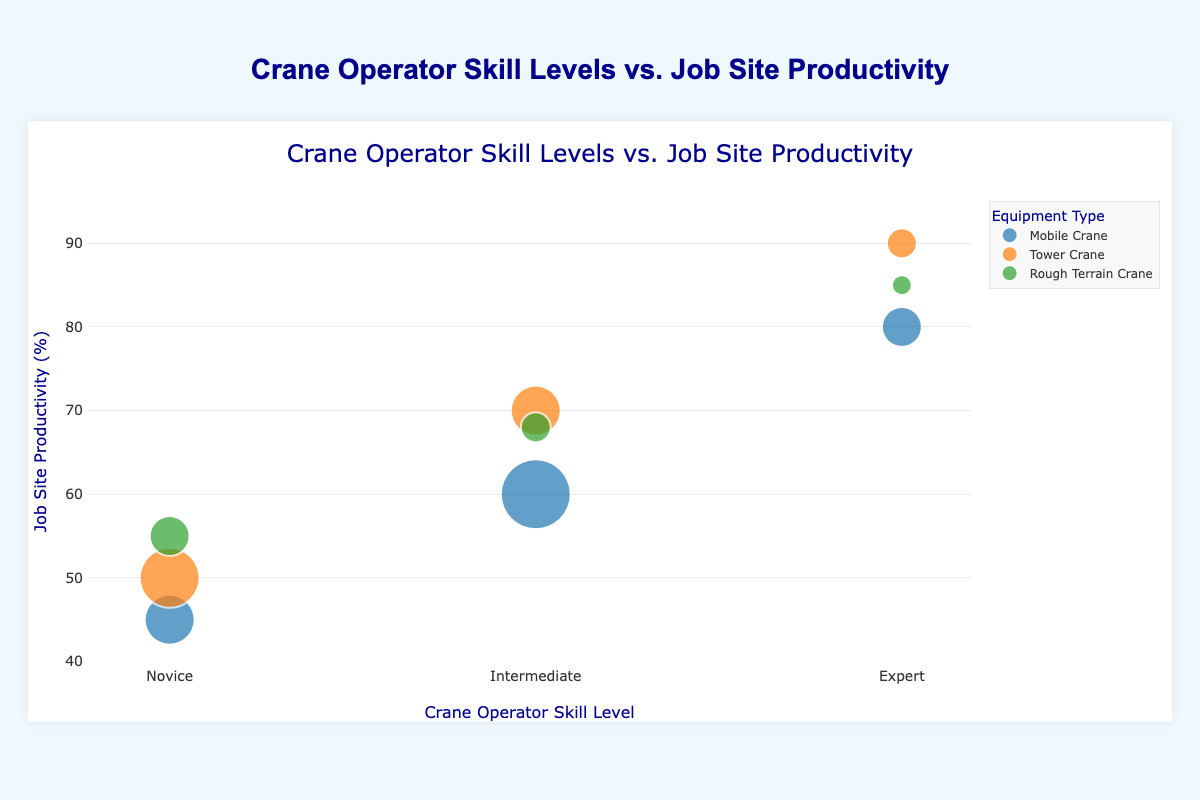what is the relationship between the skill levels of crane operators and job site productivity for tower cranes? As the skill level of crane operators increases, job site productivity also increases for tower cranes. Novice operators achieve 50%, Intermediate operators achieve 70%, and Expert operators achieve 90%.
Answer: Higher skill levels lead to higher productivity What is the number of data points in the figure? There are three equipment types (Mobile Crane, Tower Crane, Rough Terrain Crane) and each has three skill levels (Novice, Intermediate, Expert), resulting in 3 x 3 = 9 data points.
Answer: 9 What is the productivity of expert operators using Rough Terrain Cranes? According to the figure, expert operators using Rough Terrain Cranes have a job site productivity of 85%.
Answer: 85% Which equipment type has the lowest productivity for intermediate operators? By referring to the data points for intermediate operators, we see that Mobile Cranes achieve 60%, Tower Cranes achieve 70%, and Rough Terrain Cranes achieve 68%. The lowest productivity for intermediate operators is with Mobile Cranes.
Answer: Mobile Cranes How many novice operators are there for each equipment type? According to the figure:
- Mobile Cranes have 5 novice operators.
- Tower Cranes have 6 novice operators.
- Rough Terrain Cranes have 4 novice operators.
Answer: 5 for Mobile Cranes, 6 for Tower Cranes, 4 for Rough Terrain Cranes Which skill level and equipment type combination achieves the highest productivity? Reviewing all data points, Expert operators using Tower Cranes achieve the highest productivity at 90%.
Answer: Expert, Tower Crane What is the average productivity for novice operators across all equipment types? To calculate the average:
(45 + 50 + 55) / 3 = (150) / 3 = 50%
Answer: 50% How does the productivity of intermediate operators using Rough Terrain Cranes compare to that of Mobile Cranes for the same skill level? According to the figure, intermediate operators using Rough Terrain Cranes achieve 68% productivity while those using Mobile Cranes achieve 60%. Rough Terrain Cranes have a higher productivity.
Answer: Rough Terrain Cranes have higher productivity Which equipment type involves the least and greatest number of operators when considering the size of the bubbles? By comparing bubble sizes:
- Mobile Cranes involve 5 + 7 + 4 = 16 operators.
- Tower Cranes involve 6 + 5 + 3 = 14 operators.
- Rough Terrain Cranes involve 4 + 3 + 2 = 9 operators.
The least number of operators are with Rough Terrain Cranes, and the greatest with Mobile Cranes.
Answer: Rough Terrain Cranes (least), Mobile Cranes (greatest) Are expert operators more productive across all types of cranes than novice operators? Expert operators show higher productivity across all crane types when compared to novice operators:
- Mobile Cranes: Expert (80%) > Novice (45%)
- Tower Cranes: Expert (90%) > Novice (50%)
- Rough Terrain Cranes: Expert (85%) > Novice (55%)
Answer: Yes 